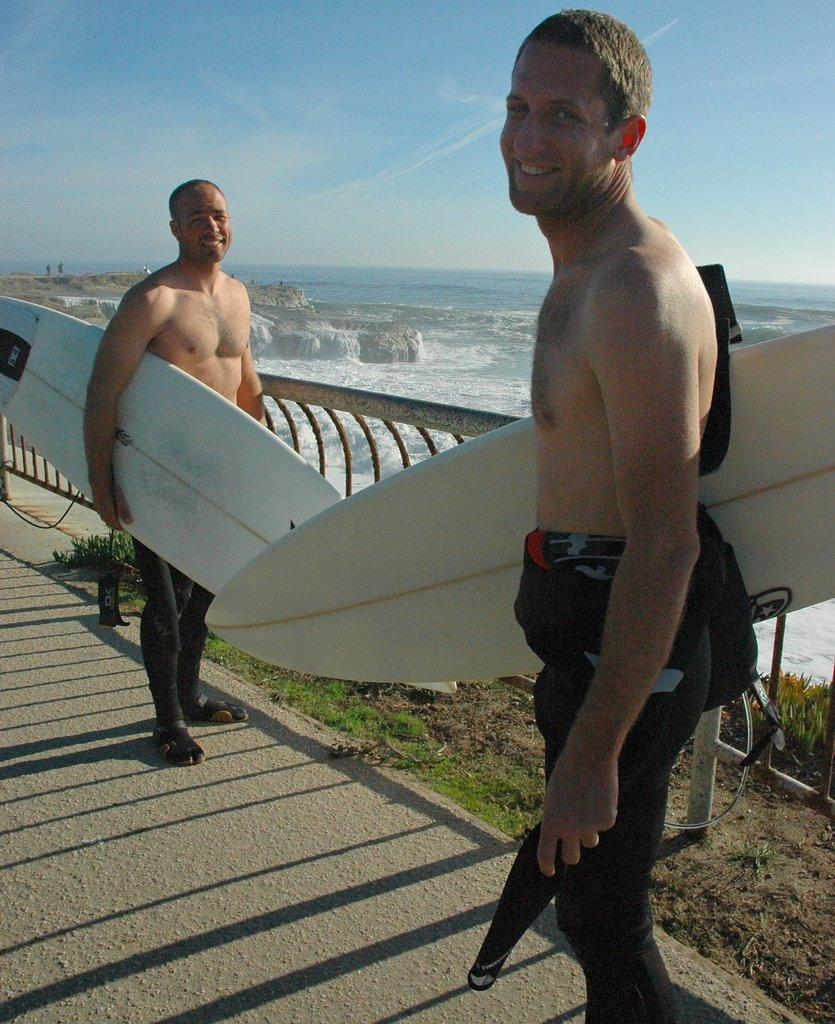How many people are in the image? There are two persons in the image. What are the persons doing in the image? The persons are standing and holding surfboards. What can be seen in the background of the image? There is water, sky, and grass visible in the background. Are there any plants in the image? Yes, there is a plant in the image. What type of hat is the person wearing in the image? There is no hat visible in the image; the persons are holding surfboards. What is the person eating for breakfast in the image? There is no breakfast or food present in the image; the focus is on the persons holding surfboards. 